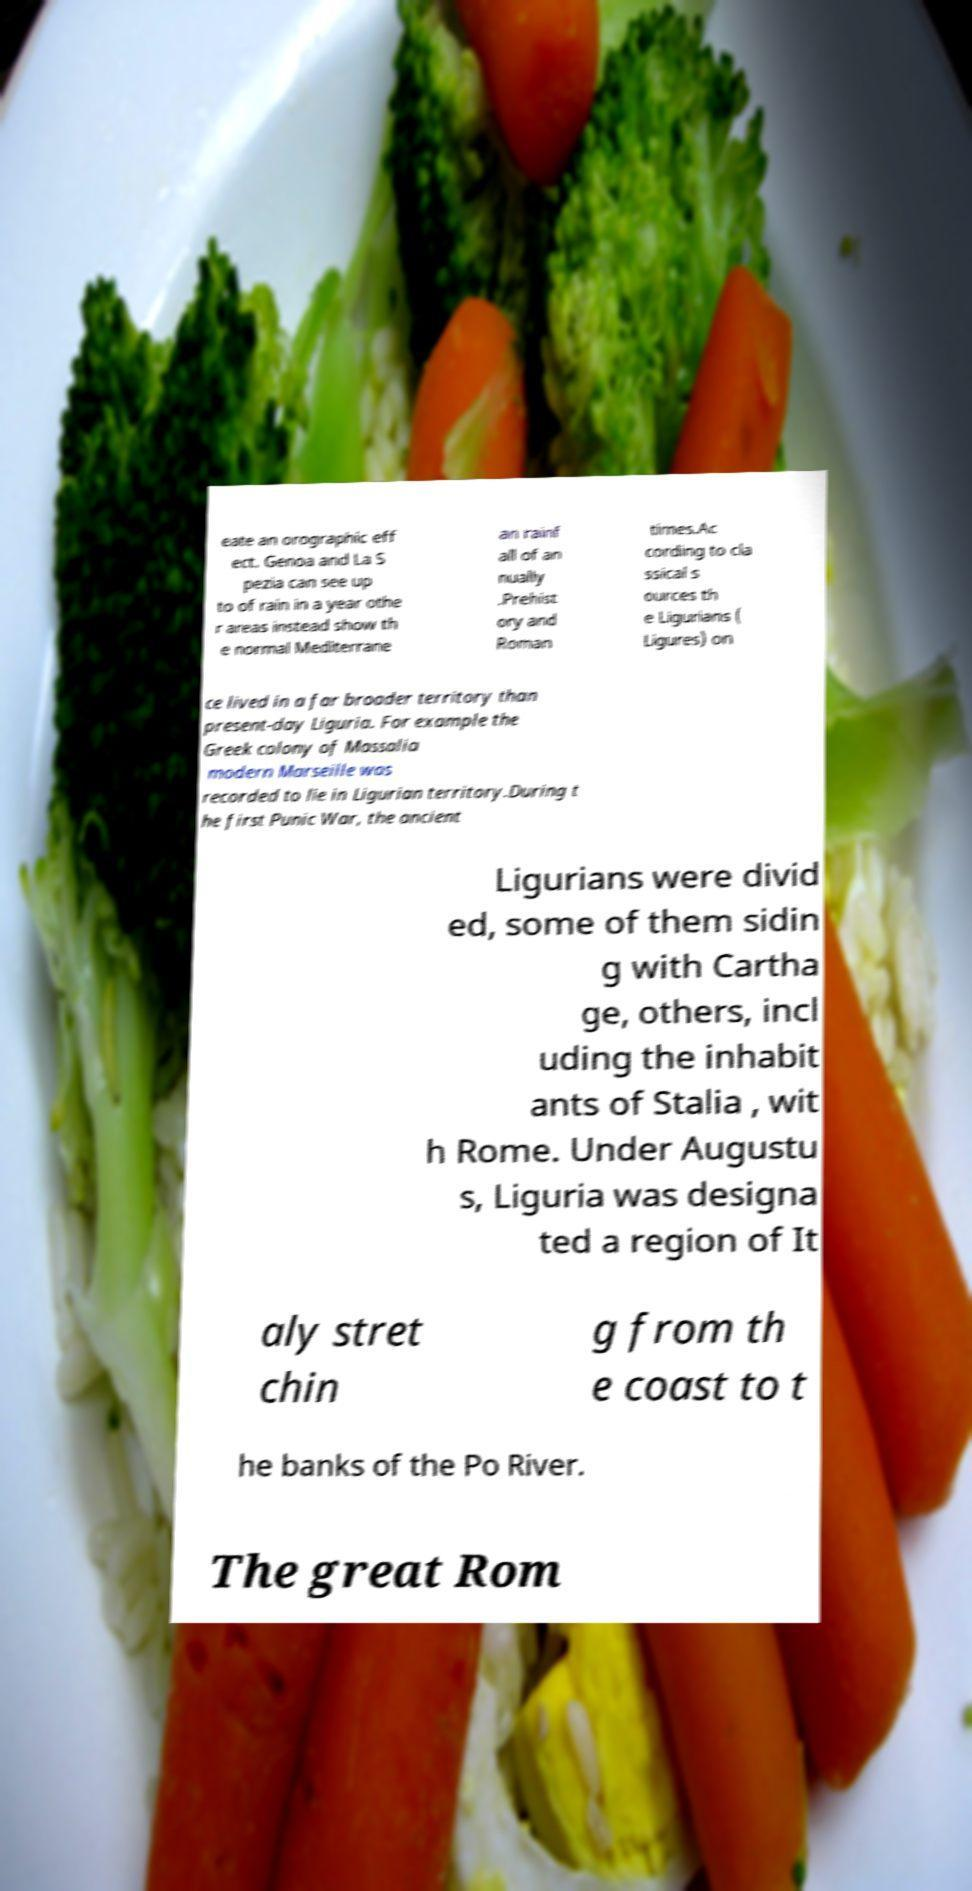There's text embedded in this image that I need extracted. Can you transcribe it verbatim? eate an orographic eff ect. Genoa and La S pezia can see up to of rain in a year othe r areas instead show th e normal Mediterrane an rainf all of an nually .Prehist ory and Roman times.Ac cording to cla ssical s ources th e Ligurians ( Ligures) on ce lived in a far broader territory than present-day Liguria. For example the Greek colony of Massalia modern Marseille was recorded to lie in Ligurian territory.During t he first Punic War, the ancient Ligurians were divid ed, some of them sidin g with Cartha ge, others, incl uding the inhabit ants of Stalia , wit h Rome. Under Augustu s, Liguria was designa ted a region of It aly stret chin g from th e coast to t he banks of the Po River. The great Rom 